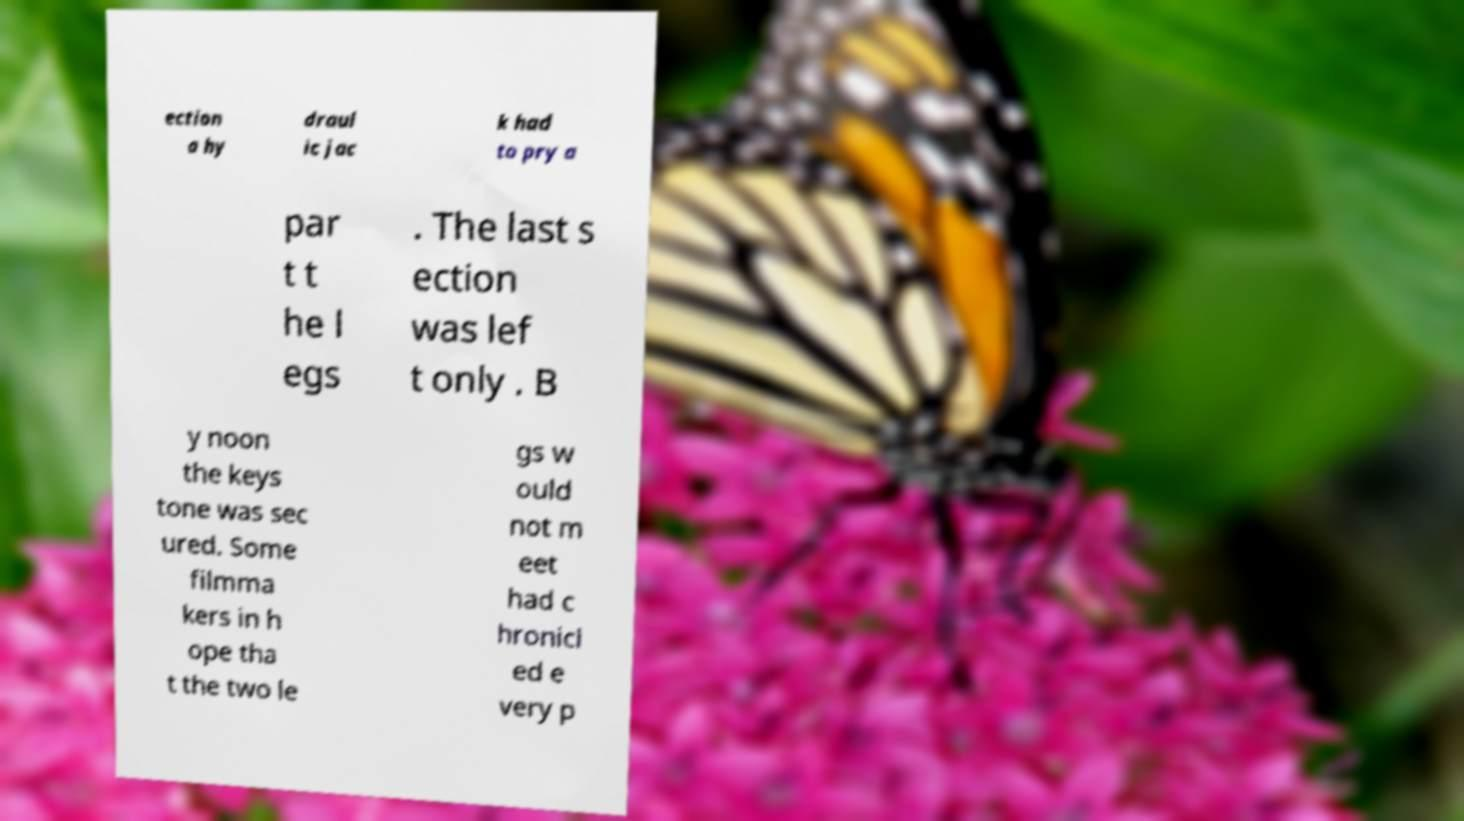Can you accurately transcribe the text from the provided image for me? ection a hy draul ic jac k had to pry a par t t he l egs . The last s ection was lef t only . B y noon the keys tone was sec ured. Some filmma kers in h ope tha t the two le gs w ould not m eet had c hronicl ed e very p 